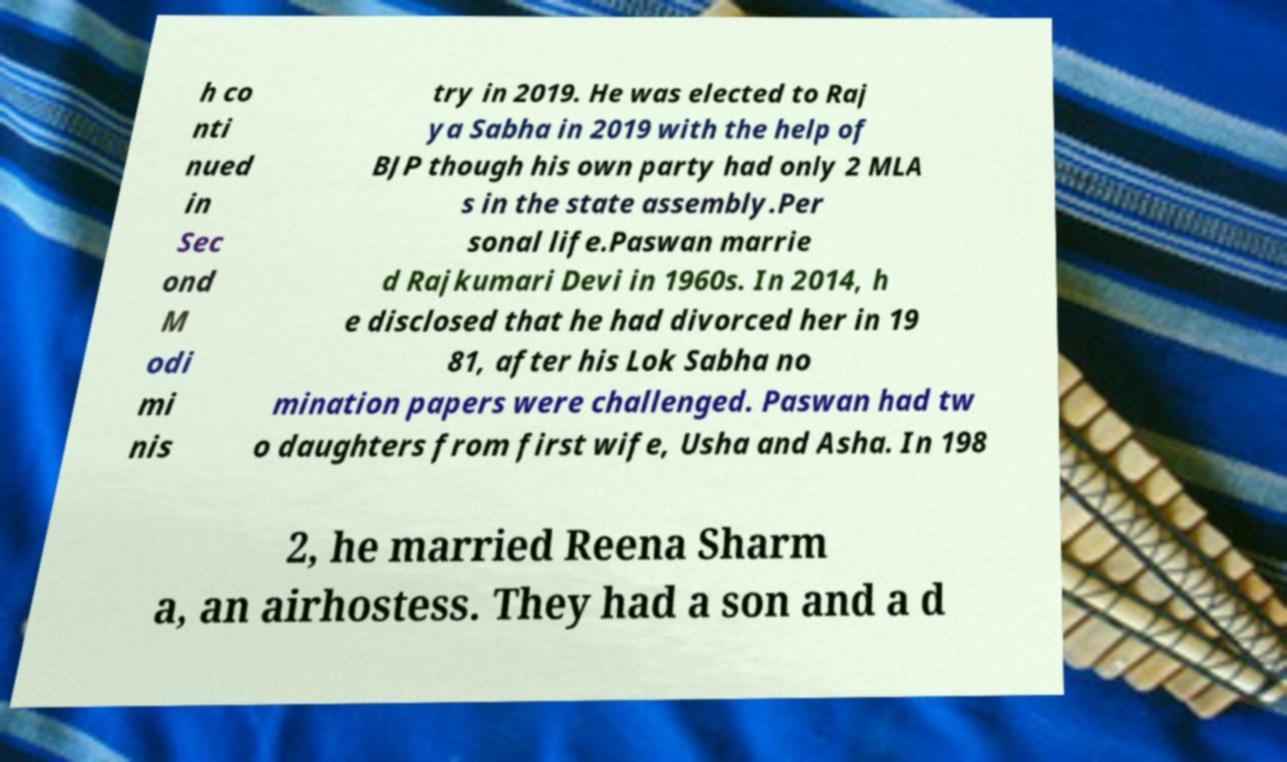Could you extract and type out the text from this image? h co nti nued in Sec ond M odi mi nis try in 2019. He was elected to Raj ya Sabha in 2019 with the help of BJP though his own party had only 2 MLA s in the state assembly.Per sonal life.Paswan marrie d Rajkumari Devi in 1960s. In 2014, h e disclosed that he had divorced her in 19 81, after his Lok Sabha no mination papers were challenged. Paswan had tw o daughters from first wife, Usha and Asha. In 198 2, he married Reena Sharm a, an airhostess. They had a son and a d 